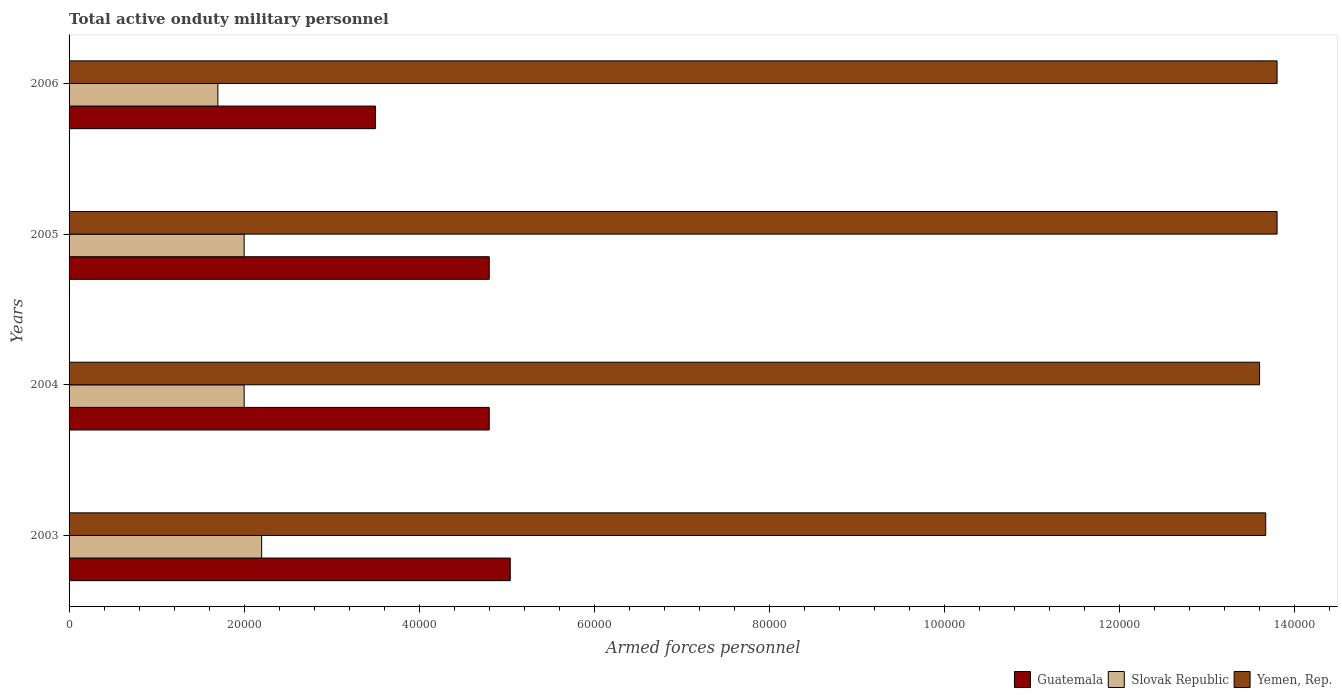How many different coloured bars are there?
Your answer should be very brief. 3. Are the number of bars per tick equal to the number of legend labels?
Ensure brevity in your answer.  Yes. How many bars are there on the 1st tick from the top?
Provide a short and direct response. 3. How many bars are there on the 3rd tick from the bottom?
Provide a succinct answer. 3. In how many cases, is the number of bars for a given year not equal to the number of legend labels?
Make the answer very short. 0. What is the number of armed forces personnel in Yemen, Rep. in 2005?
Make the answer very short. 1.38e+05. Across all years, what is the maximum number of armed forces personnel in Slovak Republic?
Offer a terse response. 2.20e+04. Across all years, what is the minimum number of armed forces personnel in Guatemala?
Ensure brevity in your answer.  3.50e+04. In which year was the number of armed forces personnel in Yemen, Rep. maximum?
Offer a very short reply. 2005. In which year was the number of armed forces personnel in Yemen, Rep. minimum?
Provide a short and direct response. 2004. What is the total number of armed forces personnel in Slovak Republic in the graph?
Give a very brief answer. 7.90e+04. What is the difference between the number of armed forces personnel in Yemen, Rep. in 2004 and that in 2005?
Your answer should be very brief. -2000. What is the difference between the number of armed forces personnel in Yemen, Rep. in 2004 and the number of armed forces personnel in Guatemala in 2006?
Provide a succinct answer. 1.01e+05. What is the average number of armed forces personnel in Guatemala per year?
Offer a very short reply. 4.54e+04. In the year 2005, what is the difference between the number of armed forces personnel in Guatemala and number of armed forces personnel in Slovak Republic?
Keep it short and to the point. 2.80e+04. In how many years, is the number of armed forces personnel in Guatemala greater than 60000 ?
Your response must be concise. 0. Is the number of armed forces personnel in Guatemala in 2003 less than that in 2004?
Your answer should be compact. No. What is the difference between the highest and the second highest number of armed forces personnel in Yemen, Rep.?
Provide a succinct answer. 0. What is the difference between the highest and the lowest number of armed forces personnel in Guatemala?
Your answer should be compact. 1.54e+04. In how many years, is the number of armed forces personnel in Yemen, Rep. greater than the average number of armed forces personnel in Yemen, Rep. taken over all years?
Provide a succinct answer. 2. Is the sum of the number of armed forces personnel in Yemen, Rep. in 2004 and 2006 greater than the maximum number of armed forces personnel in Guatemala across all years?
Your response must be concise. Yes. What does the 2nd bar from the top in 2004 represents?
Provide a succinct answer. Slovak Republic. What does the 3rd bar from the bottom in 2004 represents?
Offer a terse response. Yemen, Rep. Is it the case that in every year, the sum of the number of armed forces personnel in Slovak Republic and number of armed forces personnel in Yemen, Rep. is greater than the number of armed forces personnel in Guatemala?
Make the answer very short. Yes. How many years are there in the graph?
Keep it short and to the point. 4. What is the difference between two consecutive major ticks on the X-axis?
Offer a terse response. 2.00e+04. Does the graph contain grids?
Your answer should be compact. No. How many legend labels are there?
Ensure brevity in your answer.  3. What is the title of the graph?
Ensure brevity in your answer.  Total active onduty military personnel. Does "Malawi" appear as one of the legend labels in the graph?
Provide a short and direct response. No. What is the label or title of the X-axis?
Offer a very short reply. Armed forces personnel. What is the Armed forces personnel in Guatemala in 2003?
Provide a succinct answer. 5.04e+04. What is the Armed forces personnel of Slovak Republic in 2003?
Make the answer very short. 2.20e+04. What is the Armed forces personnel of Yemen, Rep. in 2003?
Your answer should be compact. 1.37e+05. What is the Armed forces personnel of Guatemala in 2004?
Make the answer very short. 4.80e+04. What is the Armed forces personnel in Yemen, Rep. in 2004?
Offer a terse response. 1.36e+05. What is the Armed forces personnel of Guatemala in 2005?
Provide a succinct answer. 4.80e+04. What is the Armed forces personnel in Slovak Republic in 2005?
Your answer should be very brief. 2.00e+04. What is the Armed forces personnel in Yemen, Rep. in 2005?
Your answer should be very brief. 1.38e+05. What is the Armed forces personnel in Guatemala in 2006?
Your response must be concise. 3.50e+04. What is the Armed forces personnel of Slovak Republic in 2006?
Provide a succinct answer. 1.70e+04. What is the Armed forces personnel in Yemen, Rep. in 2006?
Offer a very short reply. 1.38e+05. Across all years, what is the maximum Armed forces personnel in Guatemala?
Offer a very short reply. 5.04e+04. Across all years, what is the maximum Armed forces personnel in Slovak Republic?
Offer a very short reply. 2.20e+04. Across all years, what is the maximum Armed forces personnel of Yemen, Rep.?
Ensure brevity in your answer.  1.38e+05. Across all years, what is the minimum Armed forces personnel of Guatemala?
Provide a short and direct response. 3.50e+04. Across all years, what is the minimum Armed forces personnel of Slovak Republic?
Make the answer very short. 1.70e+04. Across all years, what is the minimum Armed forces personnel in Yemen, Rep.?
Provide a succinct answer. 1.36e+05. What is the total Armed forces personnel of Guatemala in the graph?
Offer a terse response. 1.81e+05. What is the total Armed forces personnel of Slovak Republic in the graph?
Offer a very short reply. 7.90e+04. What is the total Armed forces personnel of Yemen, Rep. in the graph?
Offer a terse response. 5.49e+05. What is the difference between the Armed forces personnel in Guatemala in 2003 and that in 2004?
Offer a very short reply. 2400. What is the difference between the Armed forces personnel of Yemen, Rep. in 2003 and that in 2004?
Your answer should be very brief. 700. What is the difference between the Armed forces personnel in Guatemala in 2003 and that in 2005?
Your answer should be very brief. 2400. What is the difference between the Armed forces personnel of Slovak Republic in 2003 and that in 2005?
Make the answer very short. 2000. What is the difference between the Armed forces personnel of Yemen, Rep. in 2003 and that in 2005?
Provide a short and direct response. -1300. What is the difference between the Armed forces personnel in Guatemala in 2003 and that in 2006?
Offer a very short reply. 1.54e+04. What is the difference between the Armed forces personnel of Slovak Republic in 2003 and that in 2006?
Make the answer very short. 5000. What is the difference between the Armed forces personnel in Yemen, Rep. in 2003 and that in 2006?
Keep it short and to the point. -1300. What is the difference between the Armed forces personnel in Slovak Republic in 2004 and that in 2005?
Make the answer very short. 0. What is the difference between the Armed forces personnel of Yemen, Rep. in 2004 and that in 2005?
Make the answer very short. -2000. What is the difference between the Armed forces personnel in Guatemala in 2004 and that in 2006?
Your answer should be compact. 1.30e+04. What is the difference between the Armed forces personnel of Slovak Republic in 2004 and that in 2006?
Make the answer very short. 3000. What is the difference between the Armed forces personnel in Yemen, Rep. in 2004 and that in 2006?
Ensure brevity in your answer.  -2000. What is the difference between the Armed forces personnel of Guatemala in 2005 and that in 2006?
Your response must be concise. 1.30e+04. What is the difference between the Armed forces personnel of Slovak Republic in 2005 and that in 2006?
Offer a terse response. 3000. What is the difference between the Armed forces personnel in Guatemala in 2003 and the Armed forces personnel in Slovak Republic in 2004?
Keep it short and to the point. 3.04e+04. What is the difference between the Armed forces personnel in Guatemala in 2003 and the Armed forces personnel in Yemen, Rep. in 2004?
Give a very brief answer. -8.56e+04. What is the difference between the Armed forces personnel in Slovak Republic in 2003 and the Armed forces personnel in Yemen, Rep. in 2004?
Your response must be concise. -1.14e+05. What is the difference between the Armed forces personnel in Guatemala in 2003 and the Armed forces personnel in Slovak Republic in 2005?
Offer a terse response. 3.04e+04. What is the difference between the Armed forces personnel of Guatemala in 2003 and the Armed forces personnel of Yemen, Rep. in 2005?
Provide a succinct answer. -8.76e+04. What is the difference between the Armed forces personnel in Slovak Republic in 2003 and the Armed forces personnel in Yemen, Rep. in 2005?
Provide a short and direct response. -1.16e+05. What is the difference between the Armed forces personnel of Guatemala in 2003 and the Armed forces personnel of Slovak Republic in 2006?
Offer a terse response. 3.34e+04. What is the difference between the Armed forces personnel of Guatemala in 2003 and the Armed forces personnel of Yemen, Rep. in 2006?
Keep it short and to the point. -8.76e+04. What is the difference between the Armed forces personnel in Slovak Republic in 2003 and the Armed forces personnel in Yemen, Rep. in 2006?
Offer a very short reply. -1.16e+05. What is the difference between the Armed forces personnel in Guatemala in 2004 and the Armed forces personnel in Slovak Republic in 2005?
Your answer should be very brief. 2.80e+04. What is the difference between the Armed forces personnel in Slovak Republic in 2004 and the Armed forces personnel in Yemen, Rep. in 2005?
Give a very brief answer. -1.18e+05. What is the difference between the Armed forces personnel of Guatemala in 2004 and the Armed forces personnel of Slovak Republic in 2006?
Keep it short and to the point. 3.10e+04. What is the difference between the Armed forces personnel of Slovak Republic in 2004 and the Armed forces personnel of Yemen, Rep. in 2006?
Provide a succinct answer. -1.18e+05. What is the difference between the Armed forces personnel in Guatemala in 2005 and the Armed forces personnel in Slovak Republic in 2006?
Give a very brief answer. 3.10e+04. What is the difference between the Armed forces personnel of Guatemala in 2005 and the Armed forces personnel of Yemen, Rep. in 2006?
Your answer should be very brief. -9.00e+04. What is the difference between the Armed forces personnel of Slovak Republic in 2005 and the Armed forces personnel of Yemen, Rep. in 2006?
Ensure brevity in your answer.  -1.18e+05. What is the average Armed forces personnel of Guatemala per year?
Provide a succinct answer. 4.54e+04. What is the average Armed forces personnel in Slovak Republic per year?
Provide a short and direct response. 1.98e+04. What is the average Armed forces personnel in Yemen, Rep. per year?
Provide a short and direct response. 1.37e+05. In the year 2003, what is the difference between the Armed forces personnel of Guatemala and Armed forces personnel of Slovak Republic?
Provide a succinct answer. 2.84e+04. In the year 2003, what is the difference between the Armed forces personnel of Guatemala and Armed forces personnel of Yemen, Rep.?
Your answer should be compact. -8.63e+04. In the year 2003, what is the difference between the Armed forces personnel in Slovak Republic and Armed forces personnel in Yemen, Rep.?
Ensure brevity in your answer.  -1.15e+05. In the year 2004, what is the difference between the Armed forces personnel in Guatemala and Armed forces personnel in Slovak Republic?
Give a very brief answer. 2.80e+04. In the year 2004, what is the difference between the Armed forces personnel of Guatemala and Armed forces personnel of Yemen, Rep.?
Provide a succinct answer. -8.80e+04. In the year 2004, what is the difference between the Armed forces personnel of Slovak Republic and Armed forces personnel of Yemen, Rep.?
Provide a short and direct response. -1.16e+05. In the year 2005, what is the difference between the Armed forces personnel of Guatemala and Armed forces personnel of Slovak Republic?
Your answer should be compact. 2.80e+04. In the year 2005, what is the difference between the Armed forces personnel in Slovak Republic and Armed forces personnel in Yemen, Rep.?
Keep it short and to the point. -1.18e+05. In the year 2006, what is the difference between the Armed forces personnel of Guatemala and Armed forces personnel of Slovak Republic?
Keep it short and to the point. 1.80e+04. In the year 2006, what is the difference between the Armed forces personnel in Guatemala and Armed forces personnel in Yemen, Rep.?
Make the answer very short. -1.03e+05. In the year 2006, what is the difference between the Armed forces personnel in Slovak Republic and Armed forces personnel in Yemen, Rep.?
Offer a terse response. -1.21e+05. What is the ratio of the Armed forces personnel of Guatemala in 2003 to that in 2005?
Your answer should be compact. 1.05. What is the ratio of the Armed forces personnel in Slovak Republic in 2003 to that in 2005?
Your answer should be compact. 1.1. What is the ratio of the Armed forces personnel of Yemen, Rep. in 2003 to that in 2005?
Your answer should be compact. 0.99. What is the ratio of the Armed forces personnel in Guatemala in 2003 to that in 2006?
Your answer should be compact. 1.44. What is the ratio of the Armed forces personnel of Slovak Republic in 2003 to that in 2006?
Provide a succinct answer. 1.29. What is the ratio of the Armed forces personnel of Yemen, Rep. in 2003 to that in 2006?
Your response must be concise. 0.99. What is the ratio of the Armed forces personnel of Slovak Republic in 2004 to that in 2005?
Keep it short and to the point. 1. What is the ratio of the Armed forces personnel of Yemen, Rep. in 2004 to that in 2005?
Ensure brevity in your answer.  0.99. What is the ratio of the Armed forces personnel of Guatemala in 2004 to that in 2006?
Your answer should be compact. 1.37. What is the ratio of the Armed forces personnel of Slovak Republic in 2004 to that in 2006?
Give a very brief answer. 1.18. What is the ratio of the Armed forces personnel of Yemen, Rep. in 2004 to that in 2006?
Keep it short and to the point. 0.99. What is the ratio of the Armed forces personnel in Guatemala in 2005 to that in 2006?
Your answer should be compact. 1.37. What is the ratio of the Armed forces personnel in Slovak Republic in 2005 to that in 2006?
Give a very brief answer. 1.18. What is the ratio of the Armed forces personnel in Yemen, Rep. in 2005 to that in 2006?
Your answer should be very brief. 1. What is the difference between the highest and the second highest Armed forces personnel in Guatemala?
Your response must be concise. 2400. What is the difference between the highest and the second highest Armed forces personnel in Slovak Republic?
Provide a succinct answer. 2000. What is the difference between the highest and the lowest Armed forces personnel in Guatemala?
Provide a succinct answer. 1.54e+04. What is the difference between the highest and the lowest Armed forces personnel of Yemen, Rep.?
Make the answer very short. 2000. 